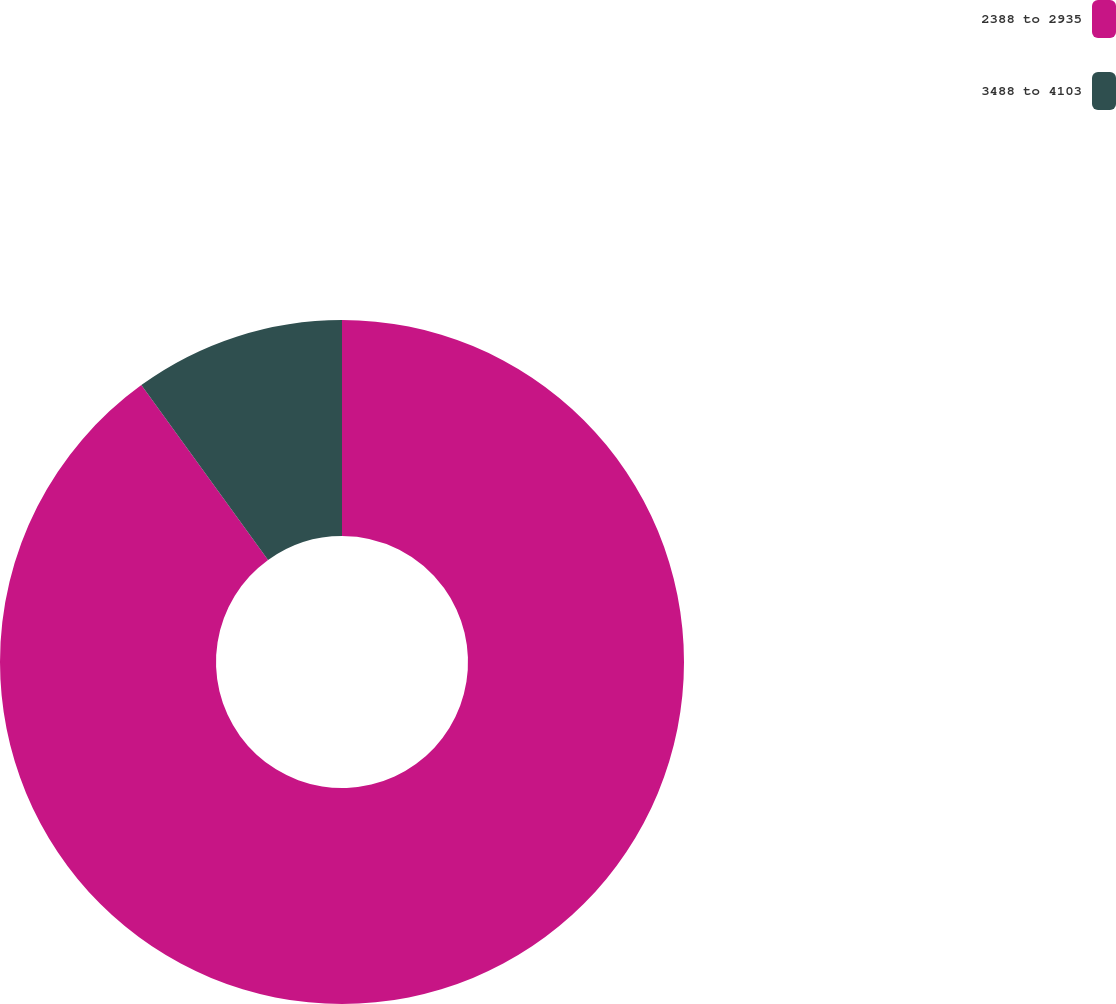Convert chart to OTSL. <chart><loc_0><loc_0><loc_500><loc_500><pie_chart><fcel>2388 to 2935<fcel>3488 to 4103<nl><fcel>90.02%<fcel>9.98%<nl></chart> 